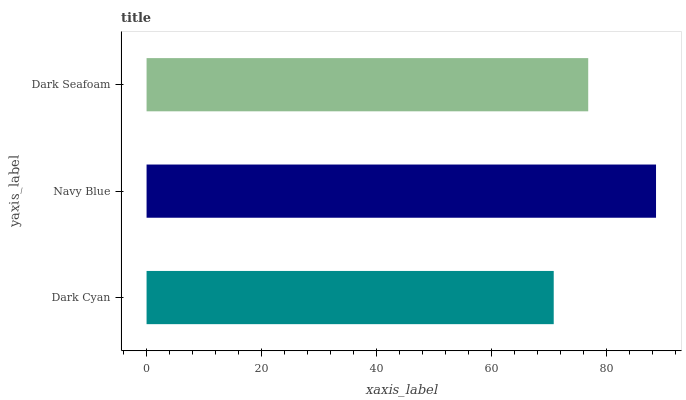Is Dark Cyan the minimum?
Answer yes or no. Yes. Is Navy Blue the maximum?
Answer yes or no. Yes. Is Dark Seafoam the minimum?
Answer yes or no. No. Is Dark Seafoam the maximum?
Answer yes or no. No. Is Navy Blue greater than Dark Seafoam?
Answer yes or no. Yes. Is Dark Seafoam less than Navy Blue?
Answer yes or no. Yes. Is Dark Seafoam greater than Navy Blue?
Answer yes or no. No. Is Navy Blue less than Dark Seafoam?
Answer yes or no. No. Is Dark Seafoam the high median?
Answer yes or no. Yes. Is Dark Seafoam the low median?
Answer yes or no. Yes. Is Navy Blue the high median?
Answer yes or no. No. Is Dark Cyan the low median?
Answer yes or no. No. 